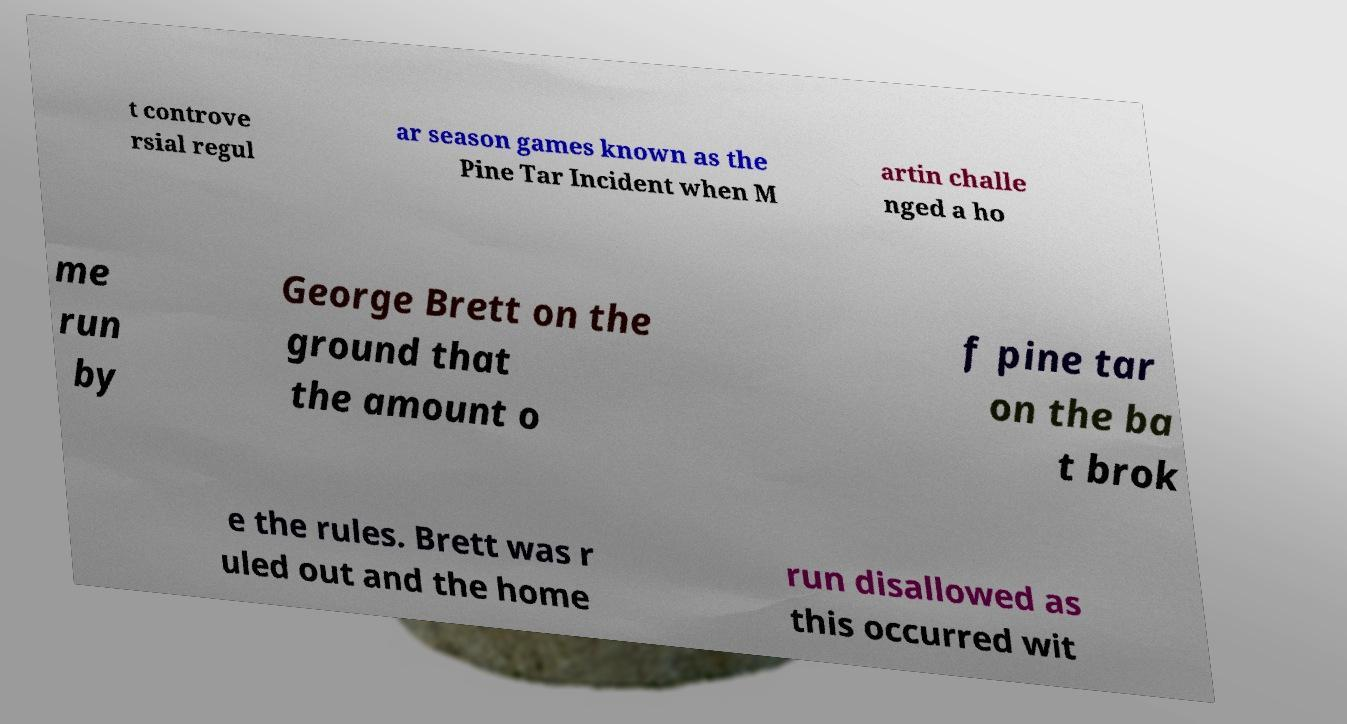Could you extract and type out the text from this image? t controve rsial regul ar season games known as the Pine Tar Incident when M artin challe nged a ho me run by George Brett on the ground that the amount o f pine tar on the ba t brok e the rules. Brett was r uled out and the home run disallowed as this occurred wit 